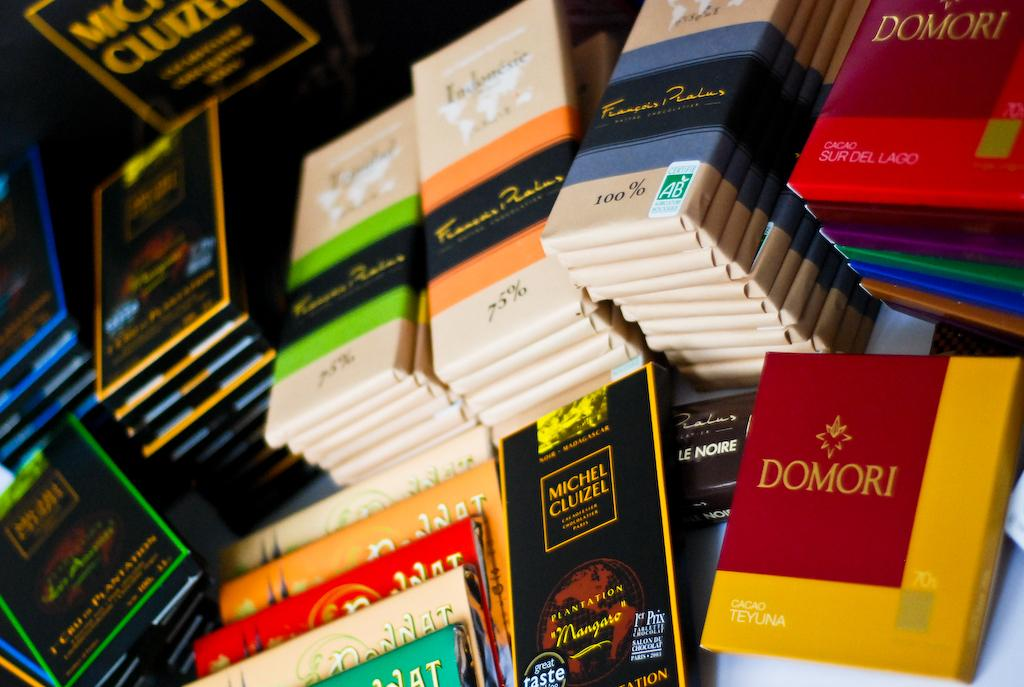<image>
Give a short and clear explanation of the subsequent image. Bars of chocolate sit stacked next to each other with one in red and yellow that says Domori. 